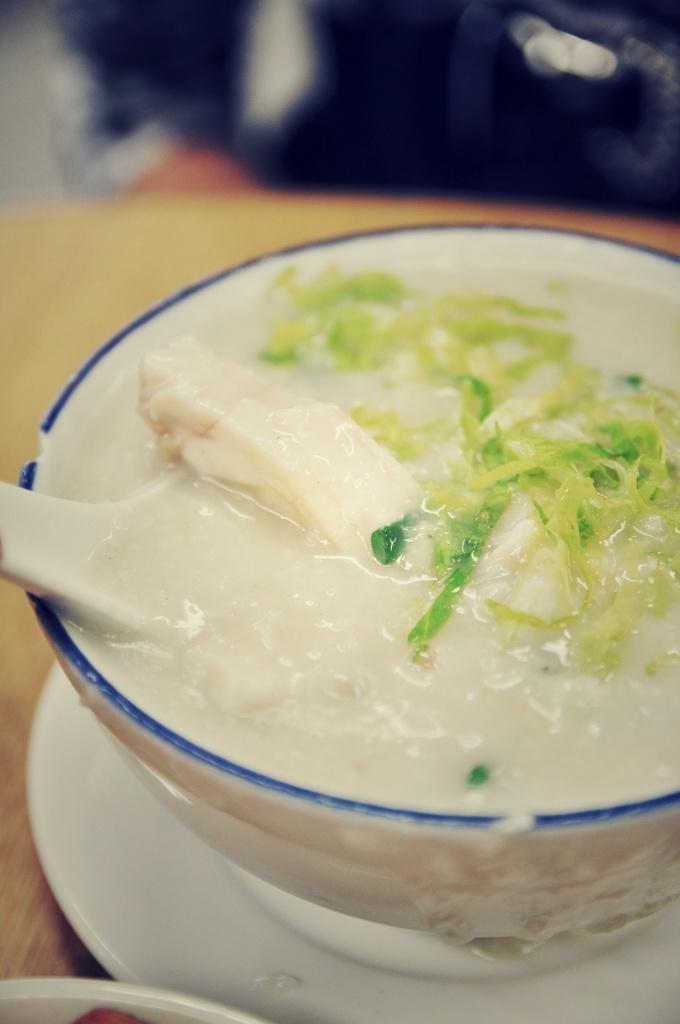In one or two sentences, can you explain what this image depicts? In the foreground of the image there is a bowl with food items. There is a spoon. There is a plate. At the bottom of the image there is table. In the background of the image there is a person. 